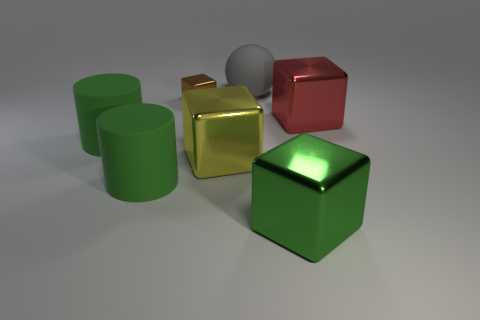Are there any other things that have the same shape as the red thing?
Keep it short and to the point. Yes. What material is the large green thing that is on the right side of the large metallic object on the left side of the large matte object behind the red shiny thing made of?
Your answer should be very brief. Metal. What is the shape of the gray rubber thing that is the same size as the red metallic object?
Keep it short and to the point. Sphere. What number of things are either big metal cubes that are left of the green metal object or rubber cylinders?
Ensure brevity in your answer.  3. Are there more big things that are in front of the brown object than rubber balls that are on the right side of the green shiny block?
Your answer should be compact. Yes. Is the red cube made of the same material as the yellow cube?
Your response must be concise. Yes. What is the shape of the large thing that is both behind the yellow block and right of the big gray object?
Provide a short and direct response. Cube. There is a red thing that is the same material as the large yellow thing; what shape is it?
Make the answer very short. Cube. Are any big brown shiny things visible?
Ensure brevity in your answer.  No. Is there a big thing that is in front of the metallic block behind the red metallic thing?
Keep it short and to the point. Yes. 